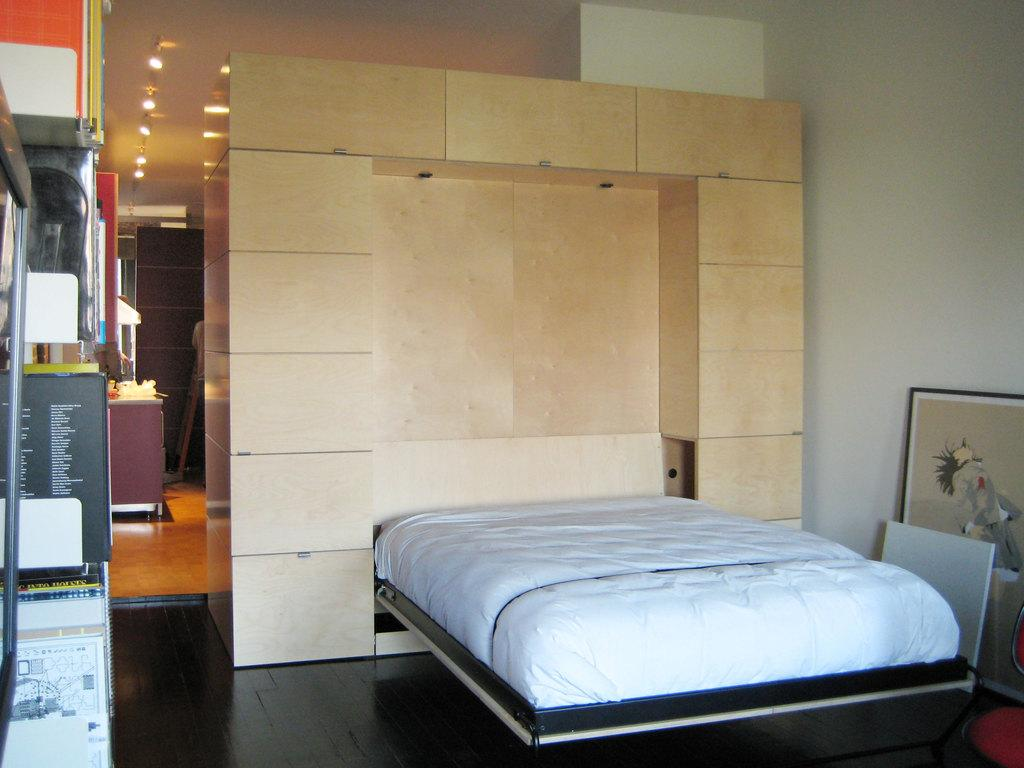What piece of furniture is located on the right side of the image? There is a bed on the right side of the image. What color is the bed? The bed is white in color. What can be seen near the bed in the image? There is a photo frame on or near the bed. What type of lighting is visible at the top of the image? There are ceiling lights at the top of the image. What type of business is being conducted in the image? There is no indication of any business being conducted in the image; it primarily features a bed and a photo frame. How is the person in the image being treated for their sneeze? There is no person sneezing or being treated in the image; it only shows a bed, a photo frame, and ceiling lights. 